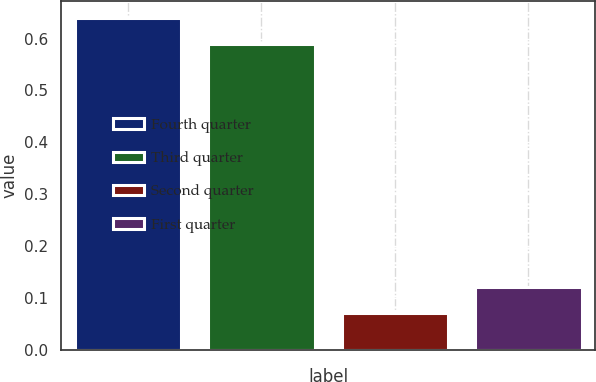<chart> <loc_0><loc_0><loc_500><loc_500><bar_chart><fcel>Fourth quarter<fcel>Third quarter<fcel>Second quarter<fcel>First quarter<nl><fcel>0.64<fcel>0.59<fcel>0.07<fcel>0.12<nl></chart> 